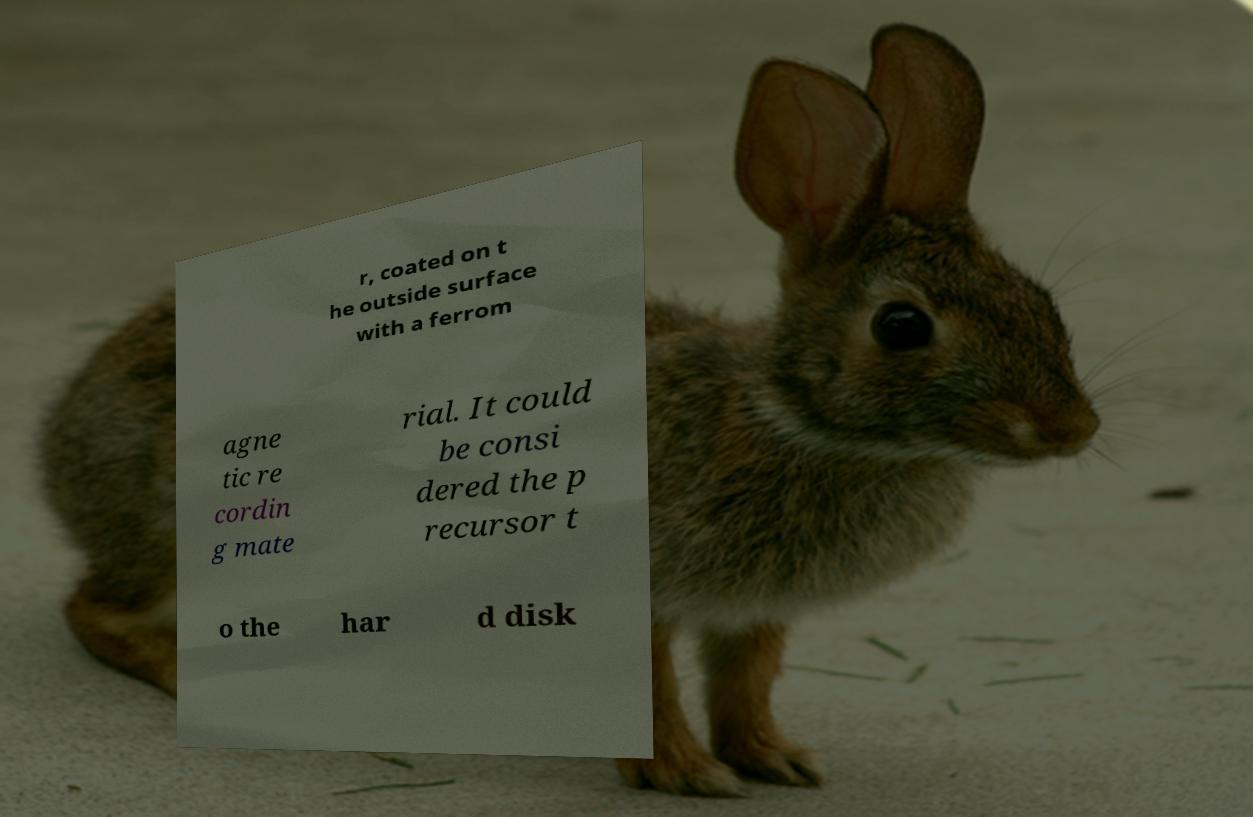Could you extract and type out the text from this image? r, coated on t he outside surface with a ferrom agne tic re cordin g mate rial. It could be consi dered the p recursor t o the har d disk 